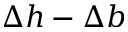Convert formula to latex. <formula><loc_0><loc_0><loc_500><loc_500>\Delta h - \Delta b</formula> 